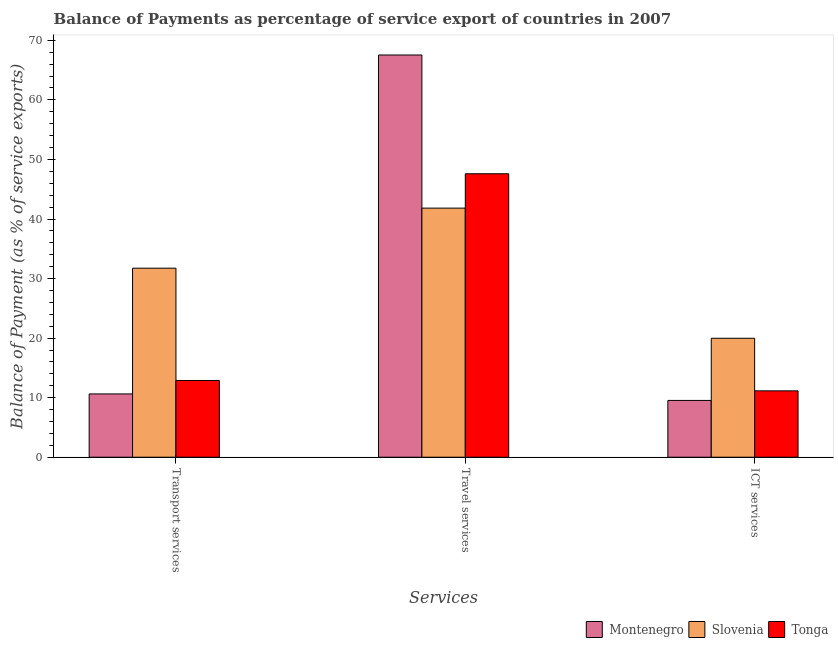How many groups of bars are there?
Offer a very short reply. 3. How many bars are there on the 3rd tick from the left?
Your answer should be compact. 3. What is the label of the 2nd group of bars from the left?
Provide a succinct answer. Travel services. What is the balance of payment of transport services in Montenegro?
Provide a succinct answer. 10.63. Across all countries, what is the maximum balance of payment of travel services?
Give a very brief answer. 67.54. Across all countries, what is the minimum balance of payment of ict services?
Provide a succinct answer. 9.54. In which country was the balance of payment of ict services maximum?
Keep it short and to the point. Slovenia. In which country was the balance of payment of transport services minimum?
Provide a short and direct response. Montenegro. What is the total balance of payment of ict services in the graph?
Your response must be concise. 40.65. What is the difference between the balance of payment of travel services in Slovenia and that in Montenegro?
Provide a short and direct response. -25.71. What is the difference between the balance of payment of travel services in Tonga and the balance of payment of transport services in Montenegro?
Offer a terse response. 36.97. What is the average balance of payment of ict services per country?
Keep it short and to the point. 13.55. What is the difference between the balance of payment of transport services and balance of payment of ict services in Slovenia?
Provide a succinct answer. 11.77. What is the ratio of the balance of payment of travel services in Montenegro to that in Slovenia?
Your response must be concise. 1.61. Is the balance of payment of transport services in Montenegro less than that in Slovenia?
Give a very brief answer. Yes. Is the difference between the balance of payment of travel services in Montenegro and Tonga greater than the difference between the balance of payment of ict services in Montenegro and Tonga?
Keep it short and to the point. Yes. What is the difference between the highest and the second highest balance of payment of transport services?
Your answer should be very brief. 18.85. What is the difference between the highest and the lowest balance of payment of ict services?
Your response must be concise. 10.44. Is the sum of the balance of payment of travel services in Tonga and Montenegro greater than the maximum balance of payment of ict services across all countries?
Keep it short and to the point. Yes. What does the 2nd bar from the left in ICT services represents?
Ensure brevity in your answer.  Slovenia. What does the 2nd bar from the right in ICT services represents?
Your answer should be compact. Slovenia. Is it the case that in every country, the sum of the balance of payment of transport services and balance of payment of travel services is greater than the balance of payment of ict services?
Your response must be concise. Yes. How many bars are there?
Ensure brevity in your answer.  9. Are the values on the major ticks of Y-axis written in scientific E-notation?
Ensure brevity in your answer.  No. Does the graph contain grids?
Offer a very short reply. No. Where does the legend appear in the graph?
Offer a very short reply. Bottom right. How many legend labels are there?
Give a very brief answer. 3. What is the title of the graph?
Your answer should be compact. Balance of Payments as percentage of service export of countries in 2007. What is the label or title of the X-axis?
Keep it short and to the point. Services. What is the label or title of the Y-axis?
Offer a very short reply. Balance of Payment (as % of service exports). What is the Balance of Payment (as % of service exports) in Montenegro in Transport services?
Keep it short and to the point. 10.63. What is the Balance of Payment (as % of service exports) in Slovenia in Transport services?
Provide a short and direct response. 31.74. What is the Balance of Payment (as % of service exports) of Tonga in Transport services?
Make the answer very short. 12.89. What is the Balance of Payment (as % of service exports) in Montenegro in Travel services?
Keep it short and to the point. 67.54. What is the Balance of Payment (as % of service exports) of Slovenia in Travel services?
Give a very brief answer. 41.83. What is the Balance of Payment (as % of service exports) in Tonga in Travel services?
Your answer should be compact. 47.6. What is the Balance of Payment (as % of service exports) in Montenegro in ICT services?
Your response must be concise. 9.54. What is the Balance of Payment (as % of service exports) in Slovenia in ICT services?
Your answer should be compact. 19.97. What is the Balance of Payment (as % of service exports) of Tonga in ICT services?
Your response must be concise. 11.14. Across all Services, what is the maximum Balance of Payment (as % of service exports) in Montenegro?
Make the answer very short. 67.54. Across all Services, what is the maximum Balance of Payment (as % of service exports) in Slovenia?
Your answer should be compact. 41.83. Across all Services, what is the maximum Balance of Payment (as % of service exports) of Tonga?
Offer a terse response. 47.6. Across all Services, what is the minimum Balance of Payment (as % of service exports) of Montenegro?
Keep it short and to the point. 9.54. Across all Services, what is the minimum Balance of Payment (as % of service exports) in Slovenia?
Provide a short and direct response. 19.97. Across all Services, what is the minimum Balance of Payment (as % of service exports) in Tonga?
Make the answer very short. 11.14. What is the total Balance of Payment (as % of service exports) in Montenegro in the graph?
Your answer should be compact. 87.7. What is the total Balance of Payment (as % of service exports) in Slovenia in the graph?
Give a very brief answer. 93.54. What is the total Balance of Payment (as % of service exports) of Tonga in the graph?
Make the answer very short. 71.63. What is the difference between the Balance of Payment (as % of service exports) of Montenegro in Transport services and that in Travel services?
Your answer should be very brief. -56.91. What is the difference between the Balance of Payment (as % of service exports) of Slovenia in Transport services and that in Travel services?
Provide a succinct answer. -10.09. What is the difference between the Balance of Payment (as % of service exports) in Tonga in Transport services and that in Travel services?
Provide a succinct answer. -34.71. What is the difference between the Balance of Payment (as % of service exports) in Montenegro in Transport services and that in ICT services?
Provide a short and direct response. 1.09. What is the difference between the Balance of Payment (as % of service exports) in Slovenia in Transport services and that in ICT services?
Provide a short and direct response. 11.77. What is the difference between the Balance of Payment (as % of service exports) in Tonga in Transport services and that in ICT services?
Your answer should be compact. 1.74. What is the difference between the Balance of Payment (as % of service exports) in Montenegro in Travel services and that in ICT services?
Ensure brevity in your answer.  58.01. What is the difference between the Balance of Payment (as % of service exports) in Slovenia in Travel services and that in ICT services?
Your answer should be very brief. 21.85. What is the difference between the Balance of Payment (as % of service exports) of Tonga in Travel services and that in ICT services?
Offer a terse response. 36.45. What is the difference between the Balance of Payment (as % of service exports) of Montenegro in Transport services and the Balance of Payment (as % of service exports) of Slovenia in Travel services?
Offer a terse response. -31.2. What is the difference between the Balance of Payment (as % of service exports) in Montenegro in Transport services and the Balance of Payment (as % of service exports) in Tonga in Travel services?
Your response must be concise. -36.97. What is the difference between the Balance of Payment (as % of service exports) in Slovenia in Transport services and the Balance of Payment (as % of service exports) in Tonga in Travel services?
Your answer should be very brief. -15.85. What is the difference between the Balance of Payment (as % of service exports) of Montenegro in Transport services and the Balance of Payment (as % of service exports) of Slovenia in ICT services?
Give a very brief answer. -9.35. What is the difference between the Balance of Payment (as % of service exports) in Montenegro in Transport services and the Balance of Payment (as % of service exports) in Tonga in ICT services?
Ensure brevity in your answer.  -0.52. What is the difference between the Balance of Payment (as % of service exports) of Slovenia in Transport services and the Balance of Payment (as % of service exports) of Tonga in ICT services?
Offer a very short reply. 20.6. What is the difference between the Balance of Payment (as % of service exports) of Montenegro in Travel services and the Balance of Payment (as % of service exports) of Slovenia in ICT services?
Offer a very short reply. 47.57. What is the difference between the Balance of Payment (as % of service exports) in Montenegro in Travel services and the Balance of Payment (as % of service exports) in Tonga in ICT services?
Your answer should be very brief. 56.4. What is the difference between the Balance of Payment (as % of service exports) of Slovenia in Travel services and the Balance of Payment (as % of service exports) of Tonga in ICT services?
Ensure brevity in your answer.  30.68. What is the average Balance of Payment (as % of service exports) of Montenegro per Services?
Make the answer very short. 29.23. What is the average Balance of Payment (as % of service exports) in Slovenia per Services?
Ensure brevity in your answer.  31.18. What is the average Balance of Payment (as % of service exports) of Tonga per Services?
Provide a short and direct response. 23.88. What is the difference between the Balance of Payment (as % of service exports) of Montenegro and Balance of Payment (as % of service exports) of Slovenia in Transport services?
Provide a short and direct response. -21.11. What is the difference between the Balance of Payment (as % of service exports) of Montenegro and Balance of Payment (as % of service exports) of Tonga in Transport services?
Keep it short and to the point. -2.26. What is the difference between the Balance of Payment (as % of service exports) in Slovenia and Balance of Payment (as % of service exports) in Tonga in Transport services?
Your response must be concise. 18.85. What is the difference between the Balance of Payment (as % of service exports) of Montenegro and Balance of Payment (as % of service exports) of Slovenia in Travel services?
Offer a terse response. 25.71. What is the difference between the Balance of Payment (as % of service exports) of Montenegro and Balance of Payment (as % of service exports) of Tonga in Travel services?
Keep it short and to the point. 19.95. What is the difference between the Balance of Payment (as % of service exports) in Slovenia and Balance of Payment (as % of service exports) in Tonga in Travel services?
Your answer should be compact. -5.77. What is the difference between the Balance of Payment (as % of service exports) in Montenegro and Balance of Payment (as % of service exports) in Slovenia in ICT services?
Offer a terse response. -10.44. What is the difference between the Balance of Payment (as % of service exports) in Montenegro and Balance of Payment (as % of service exports) in Tonga in ICT services?
Make the answer very short. -1.61. What is the difference between the Balance of Payment (as % of service exports) in Slovenia and Balance of Payment (as % of service exports) in Tonga in ICT services?
Make the answer very short. 8.83. What is the ratio of the Balance of Payment (as % of service exports) in Montenegro in Transport services to that in Travel services?
Make the answer very short. 0.16. What is the ratio of the Balance of Payment (as % of service exports) of Slovenia in Transport services to that in Travel services?
Give a very brief answer. 0.76. What is the ratio of the Balance of Payment (as % of service exports) of Tonga in Transport services to that in Travel services?
Make the answer very short. 0.27. What is the ratio of the Balance of Payment (as % of service exports) of Montenegro in Transport services to that in ICT services?
Your response must be concise. 1.11. What is the ratio of the Balance of Payment (as % of service exports) of Slovenia in Transport services to that in ICT services?
Provide a succinct answer. 1.59. What is the ratio of the Balance of Payment (as % of service exports) of Tonga in Transport services to that in ICT services?
Offer a terse response. 1.16. What is the ratio of the Balance of Payment (as % of service exports) in Montenegro in Travel services to that in ICT services?
Make the answer very short. 7.08. What is the ratio of the Balance of Payment (as % of service exports) in Slovenia in Travel services to that in ICT services?
Keep it short and to the point. 2.09. What is the ratio of the Balance of Payment (as % of service exports) in Tonga in Travel services to that in ICT services?
Your response must be concise. 4.27. What is the difference between the highest and the second highest Balance of Payment (as % of service exports) of Montenegro?
Offer a terse response. 56.91. What is the difference between the highest and the second highest Balance of Payment (as % of service exports) of Slovenia?
Your answer should be very brief. 10.09. What is the difference between the highest and the second highest Balance of Payment (as % of service exports) in Tonga?
Make the answer very short. 34.71. What is the difference between the highest and the lowest Balance of Payment (as % of service exports) in Montenegro?
Give a very brief answer. 58.01. What is the difference between the highest and the lowest Balance of Payment (as % of service exports) of Slovenia?
Offer a terse response. 21.85. What is the difference between the highest and the lowest Balance of Payment (as % of service exports) of Tonga?
Keep it short and to the point. 36.45. 